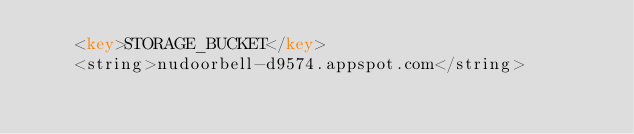<code> <loc_0><loc_0><loc_500><loc_500><_XML_>	<key>STORAGE_BUCKET</key>
	<string>nudoorbell-d9574.appspot.com</string></code> 